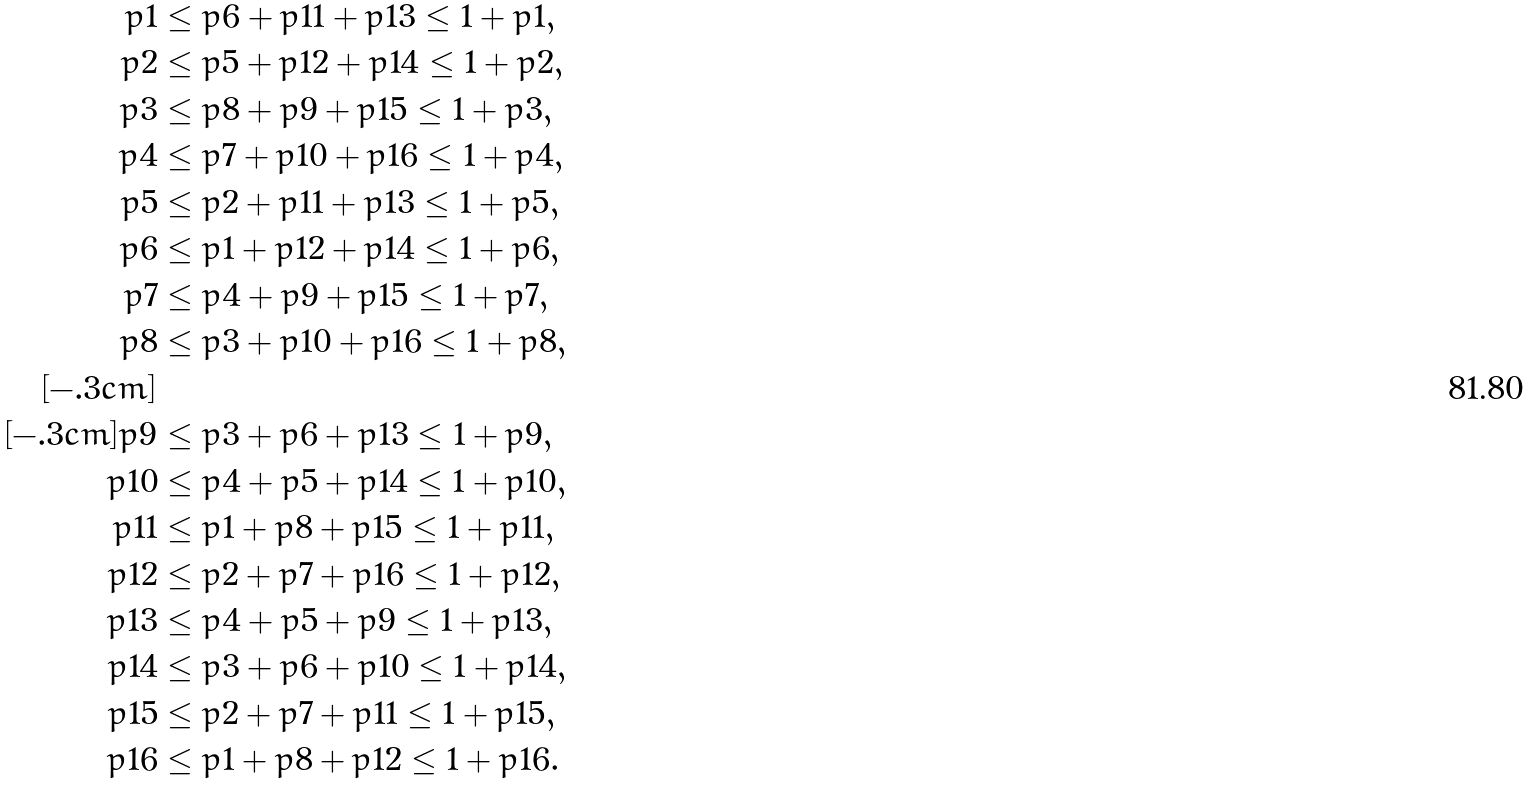Convert formula to latex. <formula><loc_0><loc_0><loc_500><loc_500>p 1 & \leq p 6 + p 1 1 + p 1 3 \leq 1 + p 1 , \\ p 2 & \leq p 5 + p 1 2 + p 1 4 \leq 1 + p 2 , \\ p 3 & \leq p 8 + p 9 + p 1 5 \leq 1 + p 3 , \\ p 4 & \leq p 7 + p 1 0 + p 1 6 \leq 1 + p 4 , \\ p 5 & \leq p 2 + p 1 1 + p 1 3 \leq 1 + p 5 , \\ p 6 & \leq p 1 + p 1 2 + p 1 4 \leq 1 + p 6 , \\ p 7 & \leq p 4 + p 9 + p 1 5 \leq 1 + p 7 , \\ p 8 & \leq p 3 + p 1 0 + p 1 6 \leq 1 + p 8 , \\ [ - . 3 c m ] & \\ [ - . 3 c m ] p 9 & \leq p 3 + p 6 + p 1 3 \leq 1 + p 9 , \\ p 1 0 & \leq p 4 + p 5 + p 1 4 \leq 1 + p 1 0 , \\ p 1 1 & \leq p 1 + p 8 + p 1 5 \leq 1 + p 1 1 , \\ p 1 2 & \leq p 2 + p 7 + p 1 6 \leq 1 + p 1 2 , \\ p 1 3 & \leq p 4 + p 5 + p 9 \leq 1 + p 1 3 , \\ p 1 4 & \leq p 3 + p 6 + p 1 0 \leq 1 + p 1 4 , \\ p 1 5 & \leq p 2 + p 7 + p 1 1 \leq 1 + p 1 5 , \\ p 1 6 & \leq p 1 + p 8 + p 1 2 \leq 1 + p 1 6 .</formula> 